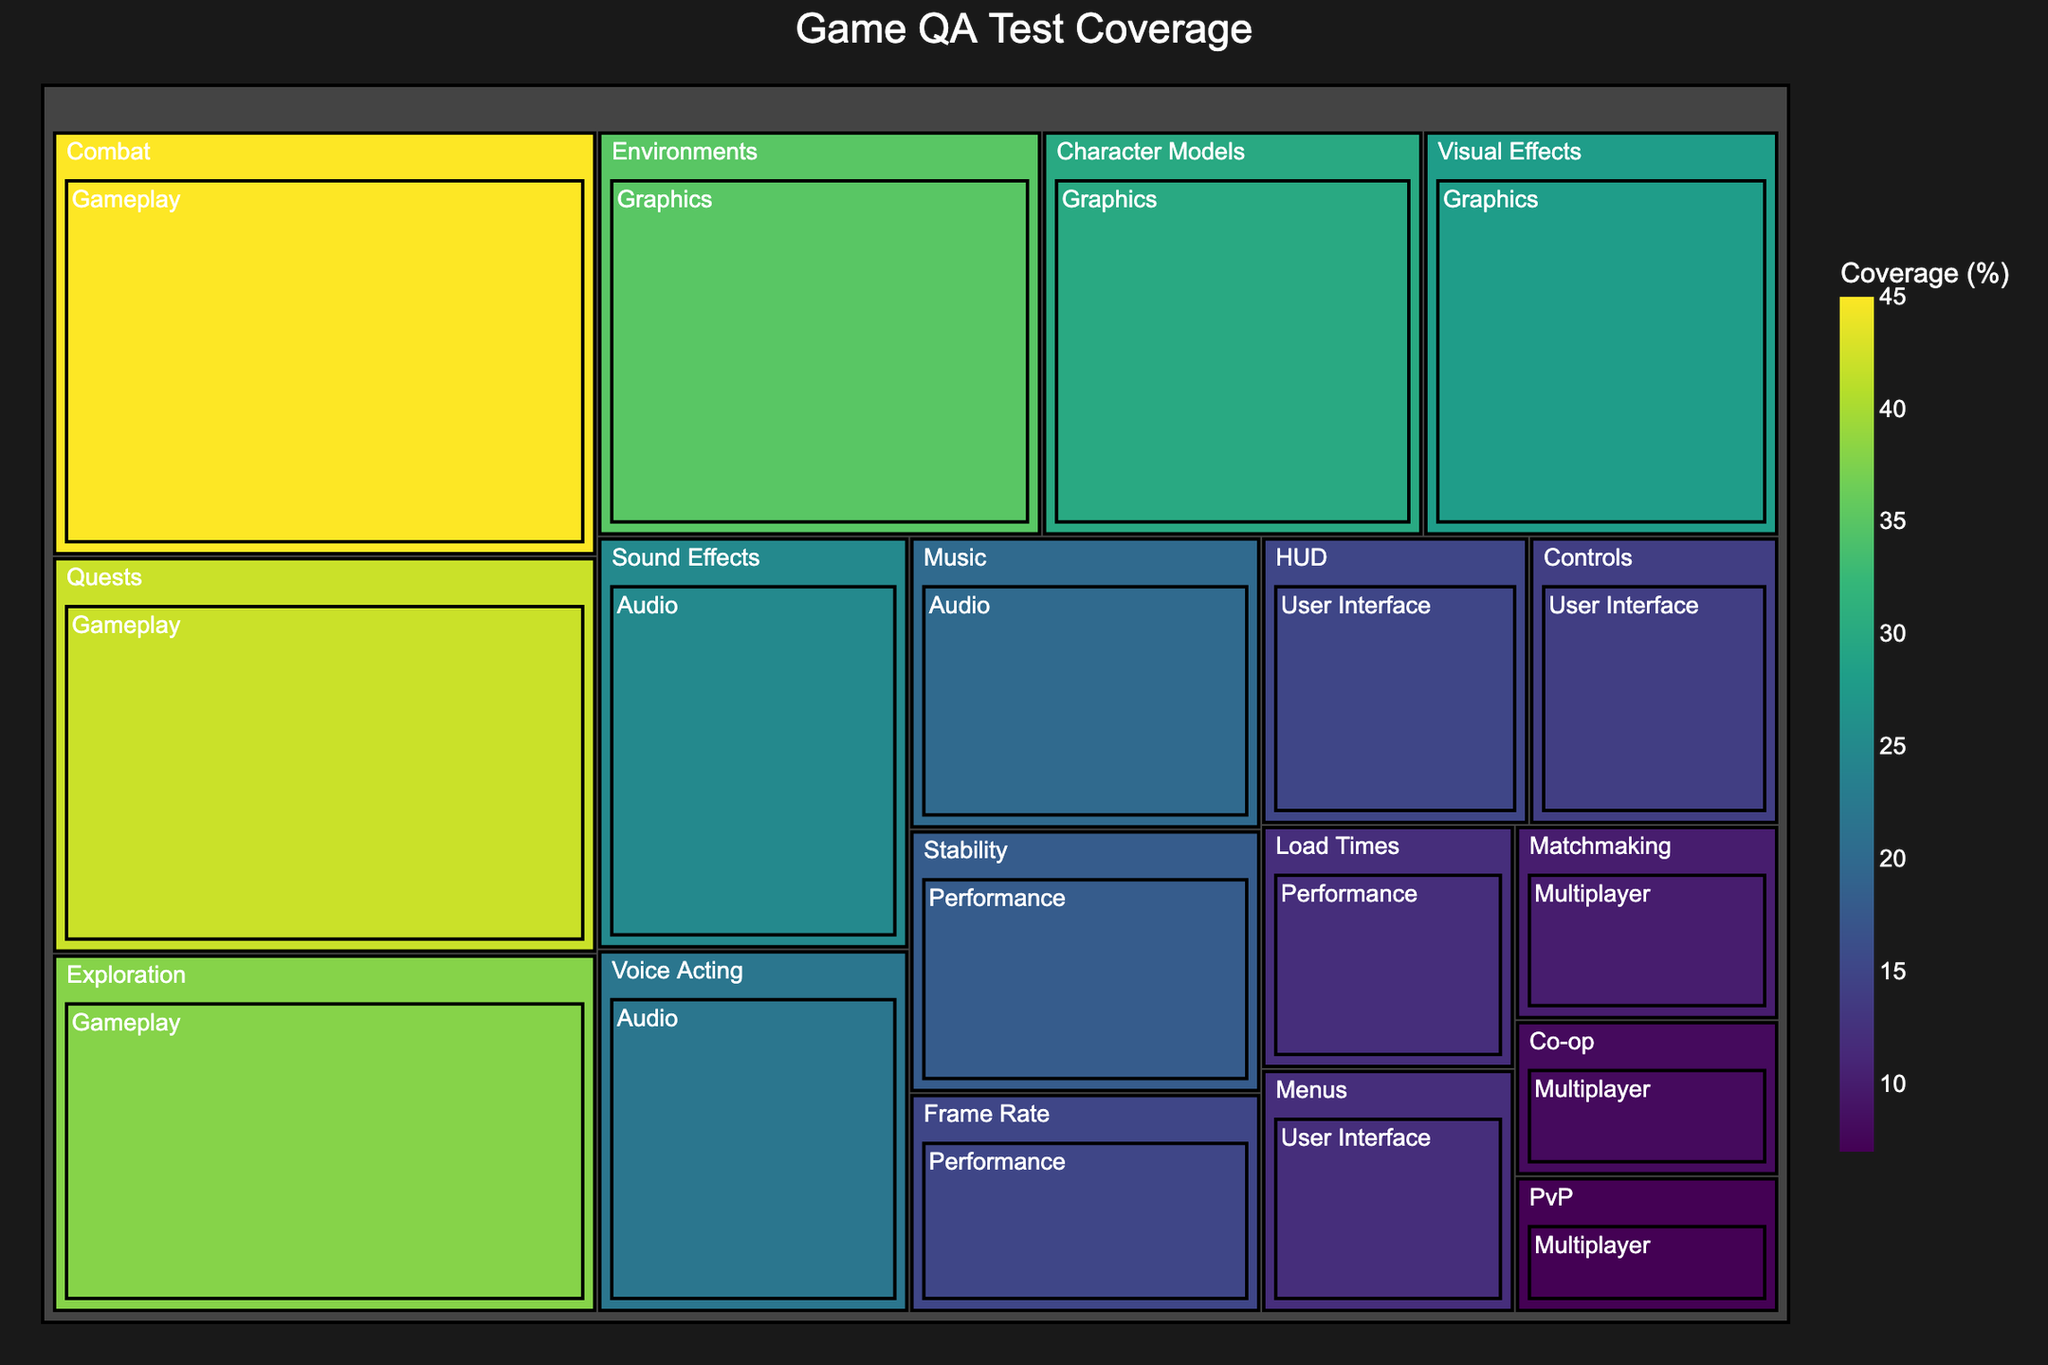What's the highest covered feature in the "Gameplay" category? The highest coverage in the "Gameplay" category can be identified by looking at the values within its section on the treemap. Combat has a coverage of 45%, which is the highest in this category.
Answer: Combat What is the total coverage percentage for the "Graphics" category? Summing up the coverage percentages for Character Models (30%), Environments (35%), and Visual Effects (28%) gives 30 + 35 + 28 = 93.
Answer: 93 Which category has the lowest coverage feature and what is that feature? By examining the treemap, the lowest coverage feature is in the "Multiplayer" category. PvP (Player vs Player) has the lowest coverage at 7%.
Answer: Multiplayer, PvP How does the coverage of "Frame Rate" compare to "Load Times" in the "Performance" category? In the "Performance" category, Frame Rate has a coverage of 15%, whereas Load Times have a coverage of 12%. Frame Rate coverage is higher.
Answer: Frame Rate has higher coverage Which category has the most equal distribution of coverage among its features? The "Gameplay" category has the most evenly distributed coverage among its features: Combat (45%), Exploration (38%), and Quests (42%). The range of coverage values (45-38=7) is smaller compared to other categories.
Answer: Gameplay What is the average coverage for the "Audio" features? The average is found by summing the coverages for "Audio" (Sound Effects: 25%, Music: 20%, Voice Acting: 22%) and dividing by the number of features, (25 + 20 + 22) / 3 = 67 / 3 ≈ 22.33.
Answer: ≈ 22.33 Which feature has higher coverage, "HUD" or "Menus" in the "User Interface" category? Comparing "HUD" with 15% and "Menus" with 12%, HUD has higher coverage.
Answer: HUD What is the title of the treemap? The title can be read directly from the figure. It is "Game QA Test Coverage".
Answer: Game QA Test Coverage What proportion of the "Multiplayer" category's total coverage is spent on "Matchmaking"? The "Multiplayer" category has features with coverages of 10%, 8%, and 7%. The total coverage is 25%. The proportion for "Matchmaking" is 10/25 = 0.4 or 40%.
Answer: 40% What are the main categories and how many are there? Main categories can be identified by the treemap structure. They are Gameplay, Graphics, Audio, Performance, Multiplayer, and User Interface. There are 6 main categories.
Answer: 6 